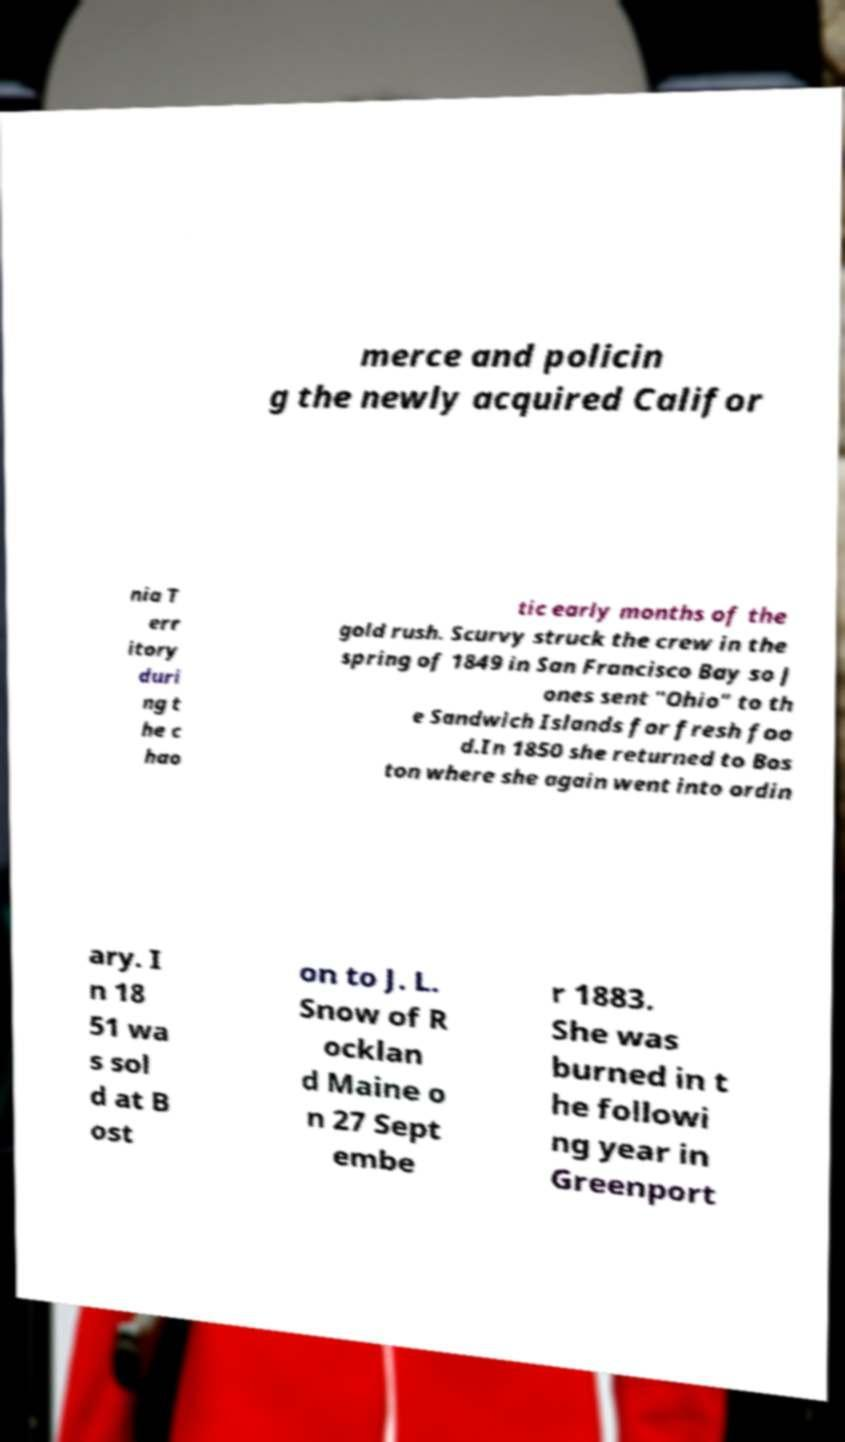There's text embedded in this image that I need extracted. Can you transcribe it verbatim? merce and policin g the newly acquired Califor nia T err itory duri ng t he c hao tic early months of the gold rush. Scurvy struck the crew in the spring of 1849 in San Francisco Bay so J ones sent "Ohio" to th e Sandwich Islands for fresh foo d.In 1850 she returned to Bos ton where she again went into ordin ary. I n 18 51 wa s sol d at B ost on to J. L. Snow of R ocklan d Maine o n 27 Sept embe r 1883. She was burned in t he followi ng year in Greenport 